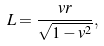<formula> <loc_0><loc_0><loc_500><loc_500>L = \frac { v r } { \sqrt { 1 - v ^ { 2 } } } ,</formula> 